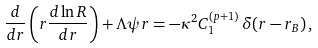Convert formula to latex. <formula><loc_0><loc_0><loc_500><loc_500>\frac { d } { d r } \left ( r \frac { d \ln R } { d r } \right ) + \Lambda \psi r = - \kappa ^ { 2 } C _ { 1 } ^ { ( p + 1 ) } \, \delta ( r - r _ { B } ) \, ,</formula> 